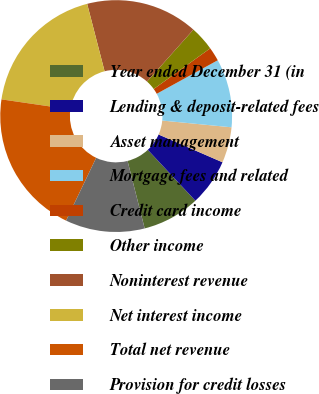<chart> <loc_0><loc_0><loc_500><loc_500><pie_chart><fcel>Year ended December 31 (in<fcel>Lending & deposit-related fees<fcel>Asset management<fcel>Mortgage fees and related<fcel>Credit card income<fcel>Other income<fcel>Noninterest revenue<fcel>Net interest income<fcel>Total net revenue<fcel>Provision for credit losses<nl><fcel>8.02%<fcel>6.5%<fcel>4.98%<fcel>9.54%<fcel>1.94%<fcel>3.46%<fcel>15.63%<fcel>18.67%<fcel>20.19%<fcel>11.06%<nl></chart> 